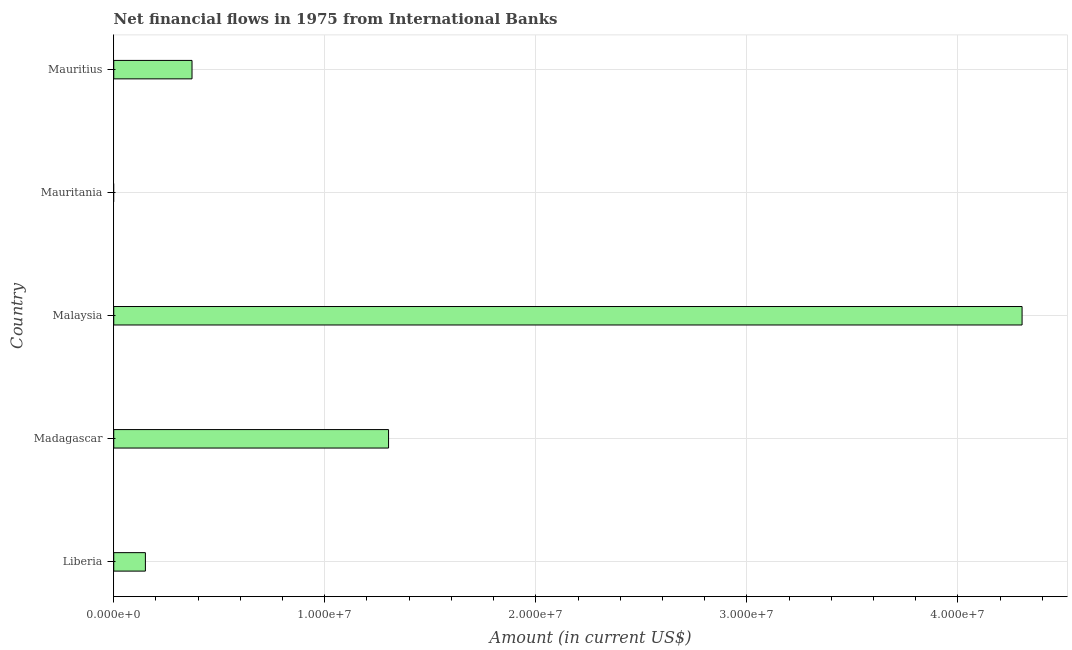Does the graph contain any zero values?
Offer a very short reply. Yes. Does the graph contain grids?
Ensure brevity in your answer.  Yes. What is the title of the graph?
Offer a very short reply. Net financial flows in 1975 from International Banks. What is the net financial flows from ibrd in Liberia?
Your answer should be compact. 1.50e+06. Across all countries, what is the maximum net financial flows from ibrd?
Give a very brief answer. 4.30e+07. In which country was the net financial flows from ibrd maximum?
Offer a very short reply. Malaysia. What is the sum of the net financial flows from ibrd?
Keep it short and to the point. 6.13e+07. What is the difference between the net financial flows from ibrd in Liberia and Mauritius?
Offer a terse response. -2.21e+06. What is the average net financial flows from ibrd per country?
Offer a terse response. 1.23e+07. What is the median net financial flows from ibrd?
Provide a short and direct response. 3.71e+06. In how many countries, is the net financial flows from ibrd greater than 2000000 US$?
Give a very brief answer. 3. What is the ratio of the net financial flows from ibrd in Liberia to that in Madagascar?
Keep it short and to the point. 0.12. Is the net financial flows from ibrd in Madagascar less than that in Mauritius?
Ensure brevity in your answer.  No. Is the difference between the net financial flows from ibrd in Liberia and Mauritius greater than the difference between any two countries?
Your response must be concise. No. What is the difference between the highest and the second highest net financial flows from ibrd?
Your response must be concise. 3.00e+07. Is the sum of the net financial flows from ibrd in Liberia and Mauritius greater than the maximum net financial flows from ibrd across all countries?
Give a very brief answer. No. What is the difference between the highest and the lowest net financial flows from ibrd?
Provide a succinct answer. 4.30e+07. Are all the bars in the graph horizontal?
Offer a terse response. Yes. How many countries are there in the graph?
Your response must be concise. 5. What is the Amount (in current US$) of Liberia?
Give a very brief answer. 1.50e+06. What is the Amount (in current US$) of Madagascar?
Give a very brief answer. 1.30e+07. What is the Amount (in current US$) of Malaysia?
Provide a short and direct response. 4.30e+07. What is the Amount (in current US$) in Mauritius?
Offer a terse response. 3.71e+06. What is the difference between the Amount (in current US$) in Liberia and Madagascar?
Give a very brief answer. -1.15e+07. What is the difference between the Amount (in current US$) in Liberia and Malaysia?
Provide a short and direct response. -4.15e+07. What is the difference between the Amount (in current US$) in Liberia and Mauritius?
Provide a succinct answer. -2.21e+06. What is the difference between the Amount (in current US$) in Madagascar and Malaysia?
Provide a short and direct response. -3.00e+07. What is the difference between the Amount (in current US$) in Madagascar and Mauritius?
Make the answer very short. 9.31e+06. What is the difference between the Amount (in current US$) in Malaysia and Mauritius?
Give a very brief answer. 3.93e+07. What is the ratio of the Amount (in current US$) in Liberia to that in Madagascar?
Your answer should be very brief. 0.12. What is the ratio of the Amount (in current US$) in Liberia to that in Malaysia?
Your answer should be very brief. 0.04. What is the ratio of the Amount (in current US$) in Liberia to that in Mauritius?
Your answer should be compact. 0.4. What is the ratio of the Amount (in current US$) in Madagascar to that in Malaysia?
Your response must be concise. 0.3. What is the ratio of the Amount (in current US$) in Madagascar to that in Mauritius?
Give a very brief answer. 3.51. What is the ratio of the Amount (in current US$) in Malaysia to that in Mauritius?
Your response must be concise. 11.6. 